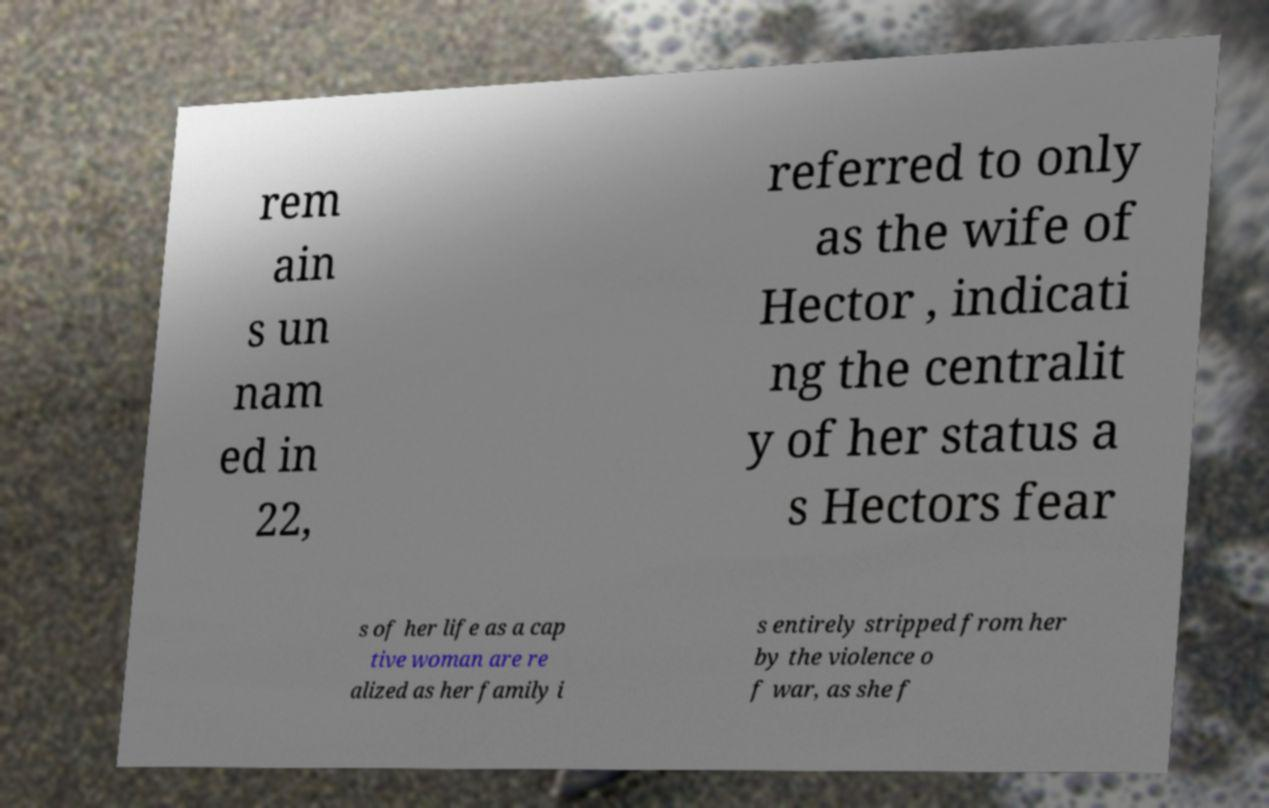There's text embedded in this image that I need extracted. Can you transcribe it verbatim? rem ain s un nam ed in 22, referred to only as the wife of Hector , indicati ng the centralit y of her status a s Hectors fear s of her life as a cap tive woman are re alized as her family i s entirely stripped from her by the violence o f war, as she f 